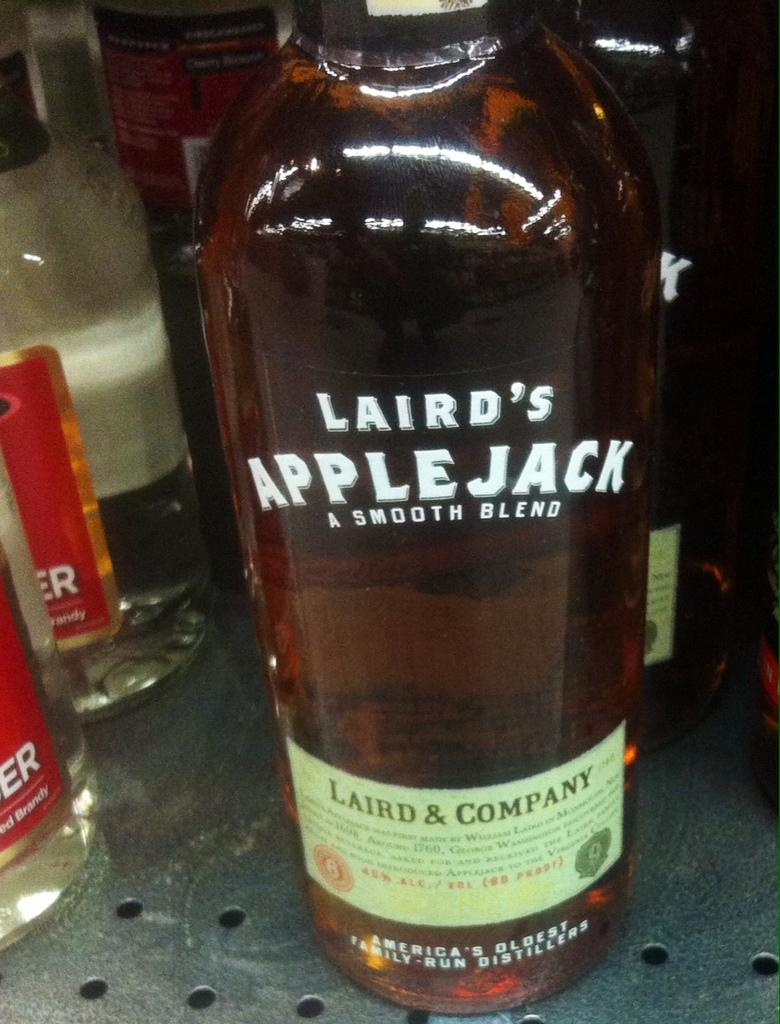What objects can be seen in the image? There are bottles in the image. Can you tell me how many tanks are visible in the image? There are no tanks present in the image; it only features bottles. What type of stream can be seen flowing through the image? There is no stream present in the image; it only features bottles. 